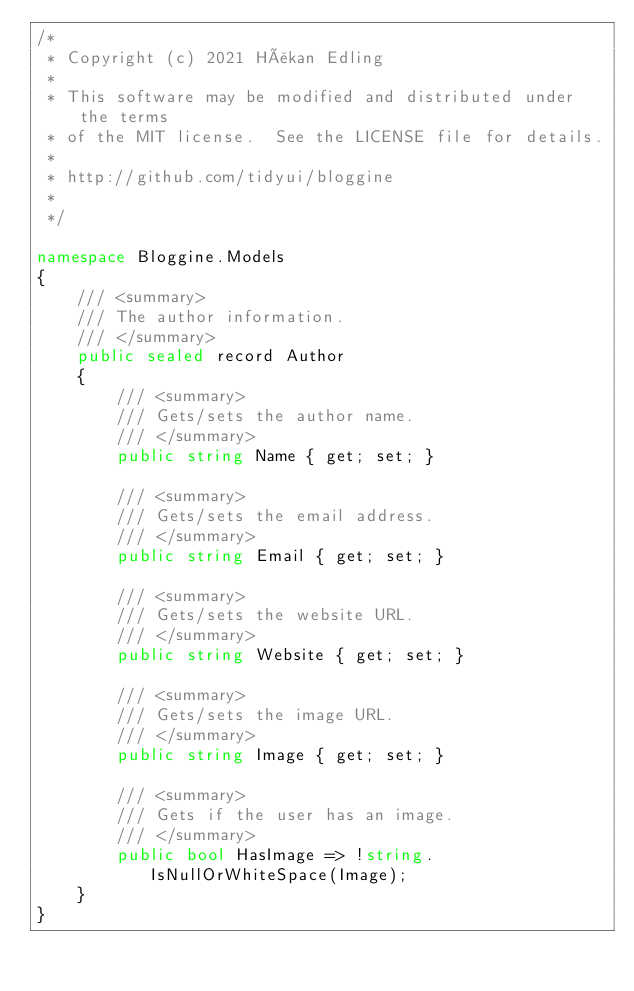<code> <loc_0><loc_0><loc_500><loc_500><_C#_>/*
 * Copyright (c) 2021 Håkan Edling
 *
 * This software may be modified and distributed under the terms
 * of the MIT license.  See the LICENSE file for details.
 *
 * http://github.com/tidyui/bloggine
 *
 */

namespace Bloggine.Models
{
    /// <summary>
    /// The author information.
    /// </summary>
    public sealed record Author
    {
        /// <summary>
        /// Gets/sets the author name.
        /// </summary>
        public string Name { get; set; }

        /// <summary>
        /// Gets/sets the email address.
        /// </summary>
        public string Email { get; set; }

        /// <summary>
        /// Gets/sets the website URL.
        /// </summary>
        public string Website { get; set; }

        /// <summary>
        /// Gets/sets the image URL.
        /// </summary>
        public string Image { get; set; }

        /// <summary>
        /// Gets if the user has an image.
        /// </summary>
        public bool HasImage => !string.IsNullOrWhiteSpace(Image);
    }
}</code> 